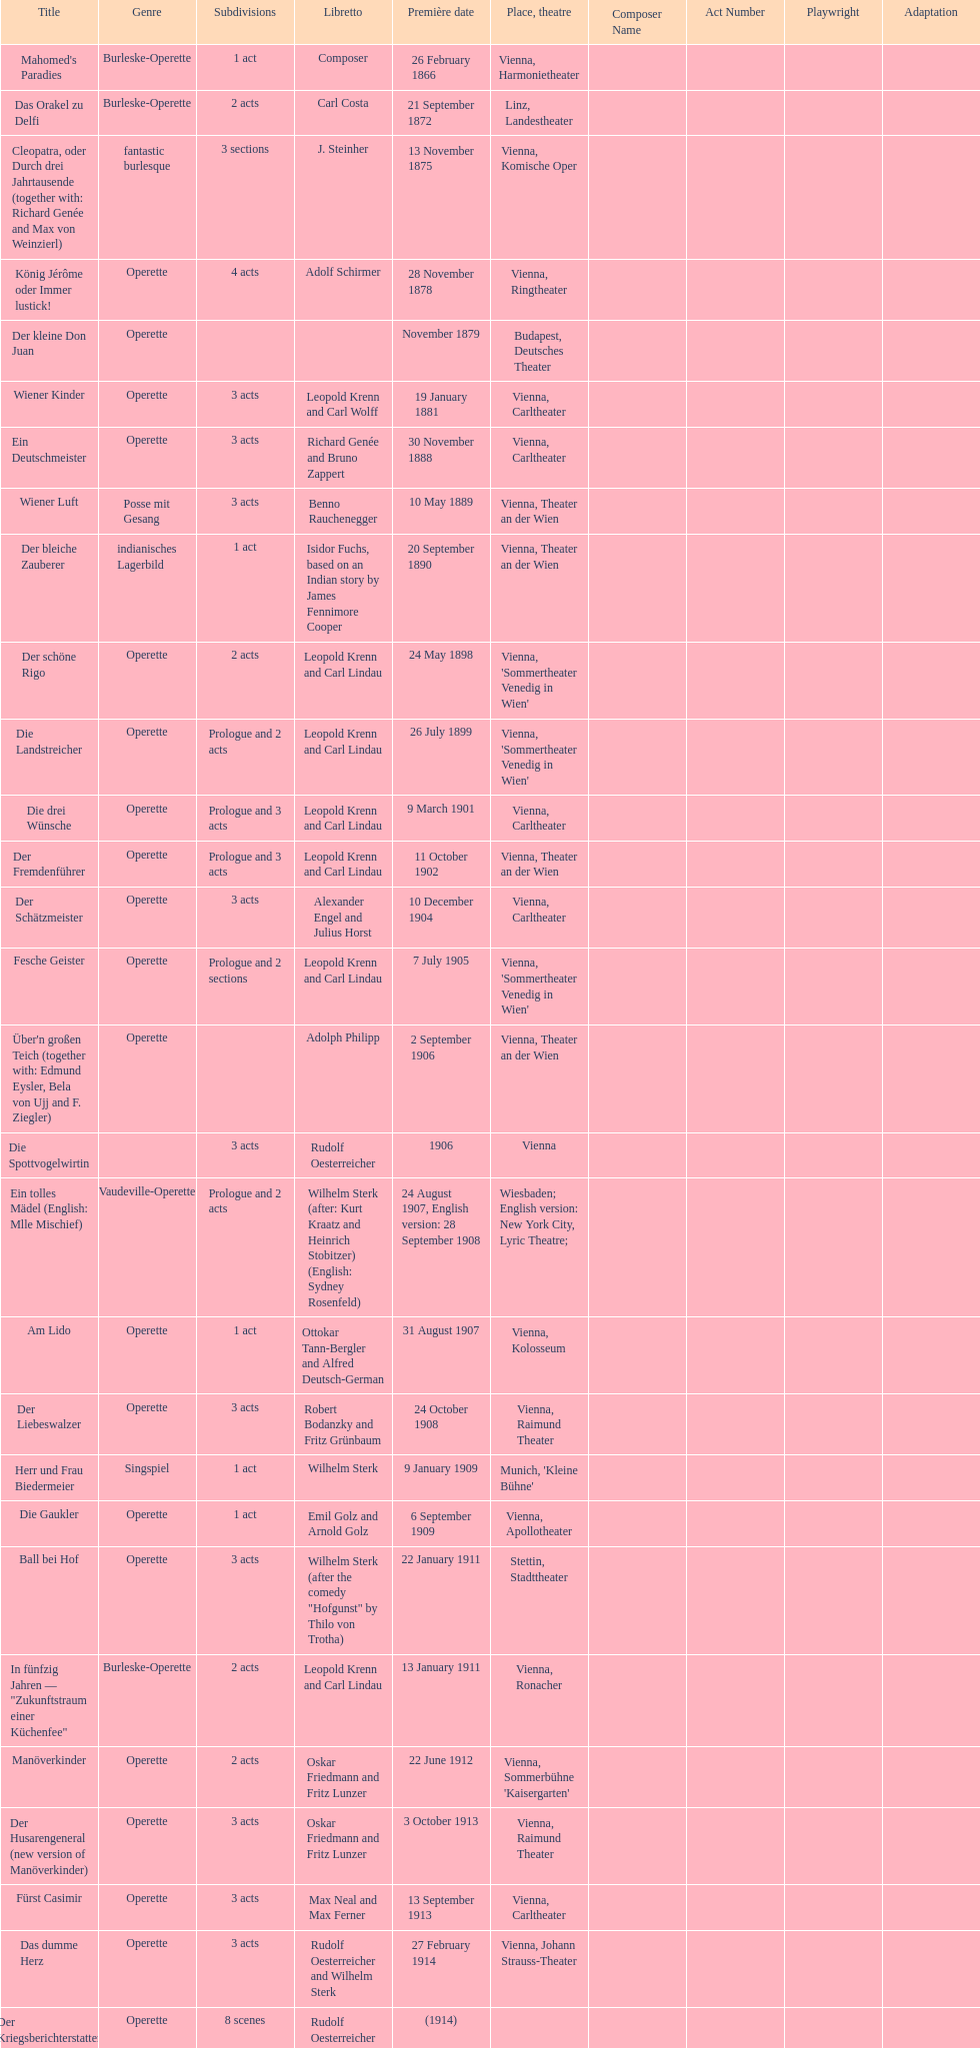What are the number of titles that premiered in the month of september? 4. 